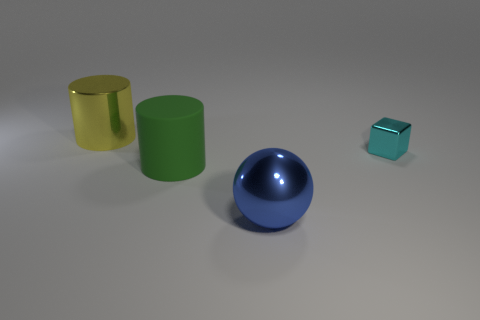Add 4 gray rubber things. How many objects exist? 8 Subtract all spheres. How many objects are left? 3 Subtract 0 red cubes. How many objects are left? 4 Subtract all small metal cubes. Subtract all tiny cyan shiny objects. How many objects are left? 2 Add 4 big green matte objects. How many big green matte objects are left? 5 Add 3 blue cylinders. How many blue cylinders exist? 3 